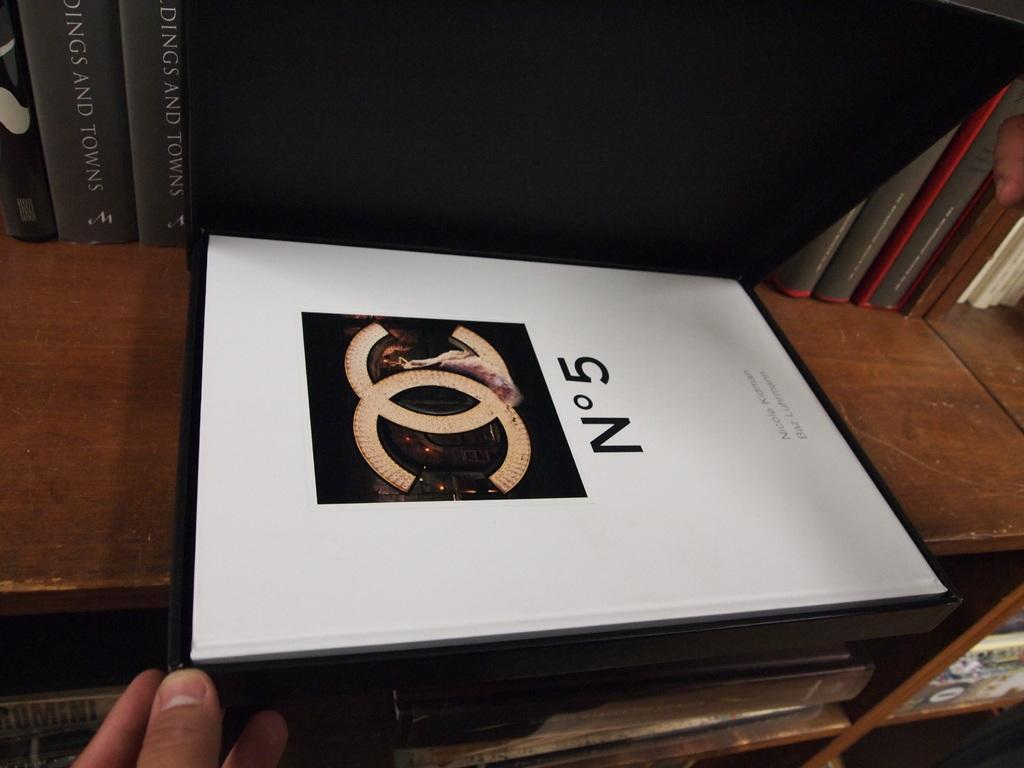<image>
Share a concise interpretation of the image provided. A Chanel N05 box that is sitting on a shelf. 